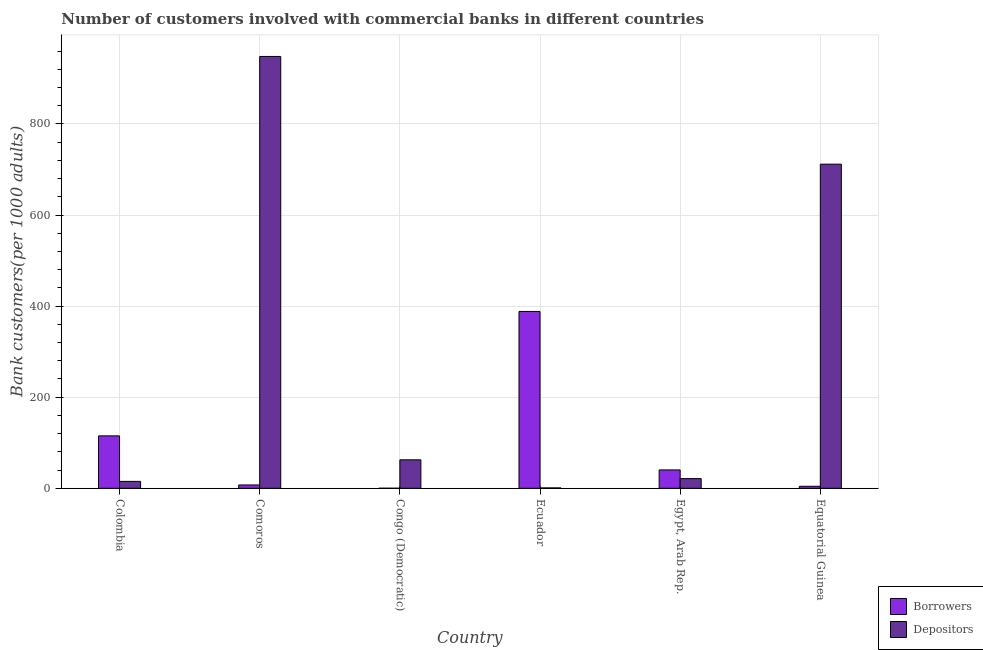How many different coloured bars are there?
Give a very brief answer. 2. How many groups of bars are there?
Give a very brief answer. 6. How many bars are there on the 3rd tick from the left?
Keep it short and to the point. 2. How many bars are there on the 5th tick from the right?
Your answer should be compact. 2. What is the label of the 5th group of bars from the left?
Ensure brevity in your answer.  Egypt, Arab Rep. In how many cases, is the number of bars for a given country not equal to the number of legend labels?
Give a very brief answer. 0. What is the number of borrowers in Egypt, Arab Rep.?
Make the answer very short. 40.3. Across all countries, what is the maximum number of borrowers?
Offer a very short reply. 388.27. Across all countries, what is the minimum number of borrowers?
Make the answer very short. 0.06. In which country was the number of borrowers maximum?
Make the answer very short. Ecuador. In which country was the number of borrowers minimum?
Your answer should be compact. Congo (Democratic). What is the total number of borrowers in the graph?
Give a very brief answer. 555.36. What is the difference between the number of depositors in Colombia and that in Ecuador?
Provide a short and direct response. 14.34. What is the difference between the number of depositors in Equatorial Guinea and the number of borrowers in Congo (Democratic)?
Provide a short and direct response. 711.62. What is the average number of depositors per country?
Offer a terse response. 293.25. What is the difference between the number of borrowers and number of depositors in Egypt, Arab Rep.?
Offer a terse response. 19.08. In how many countries, is the number of borrowers greater than 800 ?
Give a very brief answer. 0. What is the ratio of the number of depositors in Comoros to that in Congo (Democratic)?
Provide a succinct answer. 15.17. Is the number of borrowers in Colombia less than that in Ecuador?
Offer a terse response. Yes. Is the difference between the number of borrowers in Congo (Democratic) and Egypt, Arab Rep. greater than the difference between the number of depositors in Congo (Democratic) and Egypt, Arab Rep.?
Your answer should be very brief. No. What is the difference between the highest and the second highest number of depositors?
Your answer should be compact. 236.48. What is the difference between the highest and the lowest number of depositors?
Your answer should be compact. 947.35. In how many countries, is the number of borrowers greater than the average number of borrowers taken over all countries?
Give a very brief answer. 2. What does the 2nd bar from the left in Colombia represents?
Make the answer very short. Depositors. What does the 1st bar from the right in Congo (Democratic) represents?
Your response must be concise. Depositors. What is the difference between two consecutive major ticks on the Y-axis?
Your response must be concise. 200. What is the title of the graph?
Your answer should be very brief. Number of customers involved with commercial banks in different countries. What is the label or title of the Y-axis?
Provide a short and direct response. Bank customers(per 1000 adults). What is the Bank customers(per 1000 adults) of Borrowers in Colombia?
Ensure brevity in your answer.  115.09. What is the Bank customers(per 1000 adults) in Depositors in Colombia?
Ensure brevity in your answer.  15.14. What is the Bank customers(per 1000 adults) of Borrowers in Comoros?
Keep it short and to the point. 7.28. What is the Bank customers(per 1000 adults) in Depositors in Comoros?
Make the answer very short. 948.15. What is the Bank customers(per 1000 adults) in Borrowers in Congo (Democratic)?
Keep it short and to the point. 0.06. What is the Bank customers(per 1000 adults) in Depositors in Congo (Democratic)?
Your answer should be compact. 62.5. What is the Bank customers(per 1000 adults) in Borrowers in Ecuador?
Your answer should be very brief. 388.27. What is the Bank customers(per 1000 adults) in Depositors in Ecuador?
Ensure brevity in your answer.  0.8. What is the Bank customers(per 1000 adults) of Borrowers in Egypt, Arab Rep.?
Offer a very short reply. 40.3. What is the Bank customers(per 1000 adults) in Depositors in Egypt, Arab Rep.?
Your answer should be very brief. 21.22. What is the Bank customers(per 1000 adults) of Borrowers in Equatorial Guinea?
Keep it short and to the point. 4.37. What is the Bank customers(per 1000 adults) in Depositors in Equatorial Guinea?
Your answer should be very brief. 711.68. Across all countries, what is the maximum Bank customers(per 1000 adults) in Borrowers?
Your answer should be very brief. 388.27. Across all countries, what is the maximum Bank customers(per 1000 adults) of Depositors?
Offer a terse response. 948.15. Across all countries, what is the minimum Bank customers(per 1000 adults) in Borrowers?
Your answer should be compact. 0.06. Across all countries, what is the minimum Bank customers(per 1000 adults) of Depositors?
Ensure brevity in your answer.  0.8. What is the total Bank customers(per 1000 adults) of Borrowers in the graph?
Keep it short and to the point. 555.36. What is the total Bank customers(per 1000 adults) of Depositors in the graph?
Offer a very short reply. 1759.49. What is the difference between the Bank customers(per 1000 adults) in Borrowers in Colombia and that in Comoros?
Provide a short and direct response. 107.81. What is the difference between the Bank customers(per 1000 adults) in Depositors in Colombia and that in Comoros?
Provide a succinct answer. -933.01. What is the difference between the Bank customers(per 1000 adults) of Borrowers in Colombia and that in Congo (Democratic)?
Give a very brief answer. 115.04. What is the difference between the Bank customers(per 1000 adults) in Depositors in Colombia and that in Congo (Democratic)?
Offer a very short reply. -47.35. What is the difference between the Bank customers(per 1000 adults) of Borrowers in Colombia and that in Ecuador?
Offer a very short reply. -273.17. What is the difference between the Bank customers(per 1000 adults) in Depositors in Colombia and that in Ecuador?
Offer a terse response. 14.34. What is the difference between the Bank customers(per 1000 adults) in Borrowers in Colombia and that in Egypt, Arab Rep.?
Ensure brevity in your answer.  74.8. What is the difference between the Bank customers(per 1000 adults) of Depositors in Colombia and that in Egypt, Arab Rep.?
Your response must be concise. -6.08. What is the difference between the Bank customers(per 1000 adults) of Borrowers in Colombia and that in Equatorial Guinea?
Make the answer very short. 110.73. What is the difference between the Bank customers(per 1000 adults) in Depositors in Colombia and that in Equatorial Guinea?
Your response must be concise. -696.53. What is the difference between the Bank customers(per 1000 adults) of Borrowers in Comoros and that in Congo (Democratic)?
Make the answer very short. 7.22. What is the difference between the Bank customers(per 1000 adults) of Depositors in Comoros and that in Congo (Democratic)?
Keep it short and to the point. 885.66. What is the difference between the Bank customers(per 1000 adults) of Borrowers in Comoros and that in Ecuador?
Make the answer very short. -380.99. What is the difference between the Bank customers(per 1000 adults) in Depositors in Comoros and that in Ecuador?
Offer a terse response. 947.35. What is the difference between the Bank customers(per 1000 adults) of Borrowers in Comoros and that in Egypt, Arab Rep.?
Your answer should be compact. -33.02. What is the difference between the Bank customers(per 1000 adults) in Depositors in Comoros and that in Egypt, Arab Rep.?
Keep it short and to the point. 926.94. What is the difference between the Bank customers(per 1000 adults) in Borrowers in Comoros and that in Equatorial Guinea?
Keep it short and to the point. 2.91. What is the difference between the Bank customers(per 1000 adults) in Depositors in Comoros and that in Equatorial Guinea?
Give a very brief answer. 236.48. What is the difference between the Bank customers(per 1000 adults) in Borrowers in Congo (Democratic) and that in Ecuador?
Give a very brief answer. -388.21. What is the difference between the Bank customers(per 1000 adults) in Depositors in Congo (Democratic) and that in Ecuador?
Offer a terse response. 61.69. What is the difference between the Bank customers(per 1000 adults) of Borrowers in Congo (Democratic) and that in Egypt, Arab Rep.?
Ensure brevity in your answer.  -40.24. What is the difference between the Bank customers(per 1000 adults) of Depositors in Congo (Democratic) and that in Egypt, Arab Rep.?
Offer a very short reply. 41.28. What is the difference between the Bank customers(per 1000 adults) in Borrowers in Congo (Democratic) and that in Equatorial Guinea?
Offer a very short reply. -4.31. What is the difference between the Bank customers(per 1000 adults) of Depositors in Congo (Democratic) and that in Equatorial Guinea?
Offer a very short reply. -649.18. What is the difference between the Bank customers(per 1000 adults) of Borrowers in Ecuador and that in Egypt, Arab Rep.?
Your answer should be compact. 347.97. What is the difference between the Bank customers(per 1000 adults) of Depositors in Ecuador and that in Egypt, Arab Rep.?
Provide a succinct answer. -20.42. What is the difference between the Bank customers(per 1000 adults) of Borrowers in Ecuador and that in Equatorial Guinea?
Your answer should be very brief. 383.9. What is the difference between the Bank customers(per 1000 adults) of Depositors in Ecuador and that in Equatorial Guinea?
Make the answer very short. -710.87. What is the difference between the Bank customers(per 1000 adults) of Borrowers in Egypt, Arab Rep. and that in Equatorial Guinea?
Provide a succinct answer. 35.93. What is the difference between the Bank customers(per 1000 adults) in Depositors in Egypt, Arab Rep. and that in Equatorial Guinea?
Provide a short and direct response. -690.46. What is the difference between the Bank customers(per 1000 adults) in Borrowers in Colombia and the Bank customers(per 1000 adults) in Depositors in Comoros?
Give a very brief answer. -833.06. What is the difference between the Bank customers(per 1000 adults) in Borrowers in Colombia and the Bank customers(per 1000 adults) in Depositors in Congo (Democratic)?
Ensure brevity in your answer.  52.6. What is the difference between the Bank customers(per 1000 adults) in Borrowers in Colombia and the Bank customers(per 1000 adults) in Depositors in Ecuador?
Keep it short and to the point. 114.29. What is the difference between the Bank customers(per 1000 adults) in Borrowers in Colombia and the Bank customers(per 1000 adults) in Depositors in Egypt, Arab Rep.?
Your answer should be very brief. 93.88. What is the difference between the Bank customers(per 1000 adults) in Borrowers in Colombia and the Bank customers(per 1000 adults) in Depositors in Equatorial Guinea?
Keep it short and to the point. -596.58. What is the difference between the Bank customers(per 1000 adults) in Borrowers in Comoros and the Bank customers(per 1000 adults) in Depositors in Congo (Democratic)?
Keep it short and to the point. -55.22. What is the difference between the Bank customers(per 1000 adults) in Borrowers in Comoros and the Bank customers(per 1000 adults) in Depositors in Ecuador?
Provide a short and direct response. 6.48. What is the difference between the Bank customers(per 1000 adults) of Borrowers in Comoros and the Bank customers(per 1000 adults) of Depositors in Egypt, Arab Rep.?
Provide a succinct answer. -13.94. What is the difference between the Bank customers(per 1000 adults) in Borrowers in Comoros and the Bank customers(per 1000 adults) in Depositors in Equatorial Guinea?
Offer a very short reply. -704.4. What is the difference between the Bank customers(per 1000 adults) in Borrowers in Congo (Democratic) and the Bank customers(per 1000 adults) in Depositors in Ecuador?
Make the answer very short. -0.75. What is the difference between the Bank customers(per 1000 adults) of Borrowers in Congo (Democratic) and the Bank customers(per 1000 adults) of Depositors in Egypt, Arab Rep.?
Ensure brevity in your answer.  -21.16. What is the difference between the Bank customers(per 1000 adults) of Borrowers in Congo (Democratic) and the Bank customers(per 1000 adults) of Depositors in Equatorial Guinea?
Provide a short and direct response. -711.62. What is the difference between the Bank customers(per 1000 adults) of Borrowers in Ecuador and the Bank customers(per 1000 adults) of Depositors in Egypt, Arab Rep.?
Ensure brevity in your answer.  367.05. What is the difference between the Bank customers(per 1000 adults) of Borrowers in Ecuador and the Bank customers(per 1000 adults) of Depositors in Equatorial Guinea?
Your response must be concise. -323.41. What is the difference between the Bank customers(per 1000 adults) in Borrowers in Egypt, Arab Rep. and the Bank customers(per 1000 adults) in Depositors in Equatorial Guinea?
Provide a succinct answer. -671.38. What is the average Bank customers(per 1000 adults) of Borrowers per country?
Ensure brevity in your answer.  92.56. What is the average Bank customers(per 1000 adults) in Depositors per country?
Ensure brevity in your answer.  293.25. What is the difference between the Bank customers(per 1000 adults) in Borrowers and Bank customers(per 1000 adults) in Depositors in Colombia?
Your response must be concise. 99.95. What is the difference between the Bank customers(per 1000 adults) of Borrowers and Bank customers(per 1000 adults) of Depositors in Comoros?
Provide a succinct answer. -940.87. What is the difference between the Bank customers(per 1000 adults) of Borrowers and Bank customers(per 1000 adults) of Depositors in Congo (Democratic)?
Keep it short and to the point. -62.44. What is the difference between the Bank customers(per 1000 adults) of Borrowers and Bank customers(per 1000 adults) of Depositors in Ecuador?
Your answer should be compact. 387.47. What is the difference between the Bank customers(per 1000 adults) in Borrowers and Bank customers(per 1000 adults) in Depositors in Egypt, Arab Rep.?
Provide a succinct answer. 19.08. What is the difference between the Bank customers(per 1000 adults) of Borrowers and Bank customers(per 1000 adults) of Depositors in Equatorial Guinea?
Provide a succinct answer. -707.31. What is the ratio of the Bank customers(per 1000 adults) in Borrowers in Colombia to that in Comoros?
Provide a succinct answer. 15.81. What is the ratio of the Bank customers(per 1000 adults) in Depositors in Colombia to that in Comoros?
Your answer should be very brief. 0.02. What is the ratio of the Bank customers(per 1000 adults) of Borrowers in Colombia to that in Congo (Democratic)?
Keep it short and to the point. 2080.73. What is the ratio of the Bank customers(per 1000 adults) of Depositors in Colombia to that in Congo (Democratic)?
Keep it short and to the point. 0.24. What is the ratio of the Bank customers(per 1000 adults) of Borrowers in Colombia to that in Ecuador?
Keep it short and to the point. 0.3. What is the ratio of the Bank customers(per 1000 adults) in Depositors in Colombia to that in Ecuador?
Make the answer very short. 18.89. What is the ratio of the Bank customers(per 1000 adults) of Borrowers in Colombia to that in Egypt, Arab Rep.?
Keep it short and to the point. 2.86. What is the ratio of the Bank customers(per 1000 adults) in Depositors in Colombia to that in Egypt, Arab Rep.?
Keep it short and to the point. 0.71. What is the ratio of the Bank customers(per 1000 adults) of Borrowers in Colombia to that in Equatorial Guinea?
Provide a short and direct response. 26.35. What is the ratio of the Bank customers(per 1000 adults) in Depositors in Colombia to that in Equatorial Guinea?
Make the answer very short. 0.02. What is the ratio of the Bank customers(per 1000 adults) of Borrowers in Comoros to that in Congo (Democratic)?
Offer a very short reply. 131.61. What is the ratio of the Bank customers(per 1000 adults) in Depositors in Comoros to that in Congo (Democratic)?
Your answer should be very brief. 15.17. What is the ratio of the Bank customers(per 1000 adults) of Borrowers in Comoros to that in Ecuador?
Provide a succinct answer. 0.02. What is the ratio of the Bank customers(per 1000 adults) of Depositors in Comoros to that in Ecuador?
Offer a very short reply. 1182.74. What is the ratio of the Bank customers(per 1000 adults) of Borrowers in Comoros to that in Egypt, Arab Rep.?
Keep it short and to the point. 0.18. What is the ratio of the Bank customers(per 1000 adults) in Depositors in Comoros to that in Egypt, Arab Rep.?
Your response must be concise. 44.69. What is the ratio of the Bank customers(per 1000 adults) of Borrowers in Comoros to that in Equatorial Guinea?
Your answer should be compact. 1.67. What is the ratio of the Bank customers(per 1000 adults) in Depositors in Comoros to that in Equatorial Guinea?
Provide a short and direct response. 1.33. What is the ratio of the Bank customers(per 1000 adults) in Depositors in Congo (Democratic) to that in Ecuador?
Your answer should be very brief. 77.96. What is the ratio of the Bank customers(per 1000 adults) in Borrowers in Congo (Democratic) to that in Egypt, Arab Rep.?
Give a very brief answer. 0. What is the ratio of the Bank customers(per 1000 adults) in Depositors in Congo (Democratic) to that in Egypt, Arab Rep.?
Your response must be concise. 2.95. What is the ratio of the Bank customers(per 1000 adults) in Borrowers in Congo (Democratic) to that in Equatorial Guinea?
Give a very brief answer. 0.01. What is the ratio of the Bank customers(per 1000 adults) of Depositors in Congo (Democratic) to that in Equatorial Guinea?
Your answer should be very brief. 0.09. What is the ratio of the Bank customers(per 1000 adults) in Borrowers in Ecuador to that in Egypt, Arab Rep.?
Provide a succinct answer. 9.64. What is the ratio of the Bank customers(per 1000 adults) in Depositors in Ecuador to that in Egypt, Arab Rep.?
Provide a short and direct response. 0.04. What is the ratio of the Bank customers(per 1000 adults) of Borrowers in Ecuador to that in Equatorial Guinea?
Make the answer very short. 88.9. What is the ratio of the Bank customers(per 1000 adults) in Depositors in Ecuador to that in Equatorial Guinea?
Provide a short and direct response. 0. What is the ratio of the Bank customers(per 1000 adults) of Borrowers in Egypt, Arab Rep. to that in Equatorial Guinea?
Offer a very short reply. 9.23. What is the ratio of the Bank customers(per 1000 adults) in Depositors in Egypt, Arab Rep. to that in Equatorial Guinea?
Your answer should be compact. 0.03. What is the difference between the highest and the second highest Bank customers(per 1000 adults) of Borrowers?
Ensure brevity in your answer.  273.17. What is the difference between the highest and the second highest Bank customers(per 1000 adults) in Depositors?
Give a very brief answer. 236.48. What is the difference between the highest and the lowest Bank customers(per 1000 adults) of Borrowers?
Ensure brevity in your answer.  388.21. What is the difference between the highest and the lowest Bank customers(per 1000 adults) in Depositors?
Offer a very short reply. 947.35. 